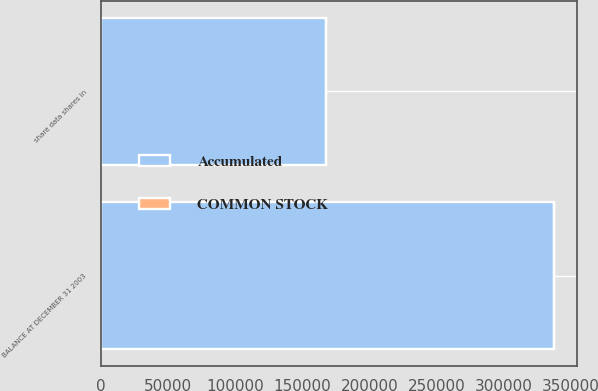Convert chart. <chart><loc_0><loc_0><loc_500><loc_500><stacked_bar_chart><ecel><fcel>share data shares in<fcel>BALANCE AT DECEMBER 31 2003<nl><fcel>Accumulated<fcel>167219<fcel>337132<nl><fcel>COMMON STOCK<fcel>1<fcel>192<nl></chart> 